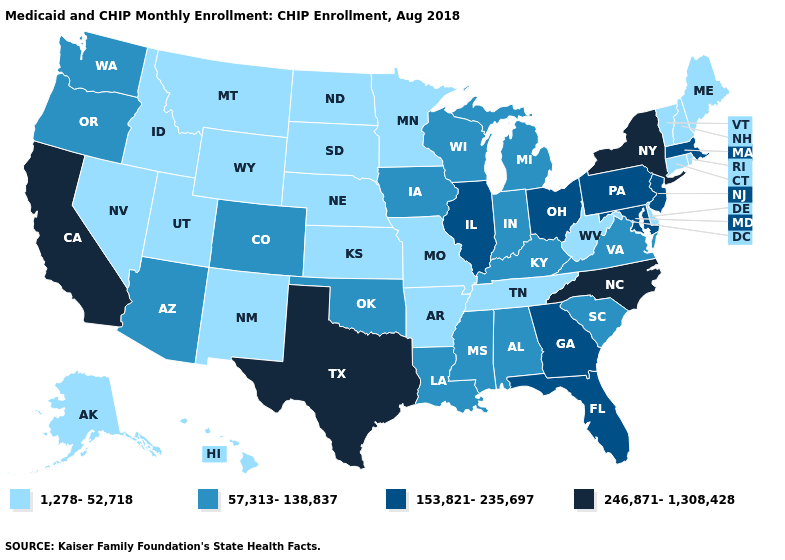Does the map have missing data?
Write a very short answer. No. What is the lowest value in states that border Minnesota?
Give a very brief answer. 1,278-52,718. Among the states that border Georgia , which have the highest value?
Write a very short answer. North Carolina. What is the value of North Dakota?
Short answer required. 1,278-52,718. Name the states that have a value in the range 1,278-52,718?
Answer briefly. Alaska, Arkansas, Connecticut, Delaware, Hawaii, Idaho, Kansas, Maine, Minnesota, Missouri, Montana, Nebraska, Nevada, New Hampshire, New Mexico, North Dakota, Rhode Island, South Dakota, Tennessee, Utah, Vermont, West Virginia, Wyoming. What is the value of Virginia?
Quick response, please. 57,313-138,837. What is the value of Georgia?
Be succinct. 153,821-235,697. Name the states that have a value in the range 246,871-1,308,428?
Concise answer only. California, New York, North Carolina, Texas. Does Virginia have the lowest value in the South?
Concise answer only. No. What is the value of North Dakota?
Be succinct. 1,278-52,718. What is the value of Oklahoma?
Answer briefly. 57,313-138,837. Name the states that have a value in the range 57,313-138,837?
Write a very short answer. Alabama, Arizona, Colorado, Indiana, Iowa, Kentucky, Louisiana, Michigan, Mississippi, Oklahoma, Oregon, South Carolina, Virginia, Washington, Wisconsin. What is the lowest value in the West?
Answer briefly. 1,278-52,718. Name the states that have a value in the range 1,278-52,718?
Keep it brief. Alaska, Arkansas, Connecticut, Delaware, Hawaii, Idaho, Kansas, Maine, Minnesota, Missouri, Montana, Nebraska, Nevada, New Hampshire, New Mexico, North Dakota, Rhode Island, South Dakota, Tennessee, Utah, Vermont, West Virginia, Wyoming. What is the lowest value in the USA?
Short answer required. 1,278-52,718. 